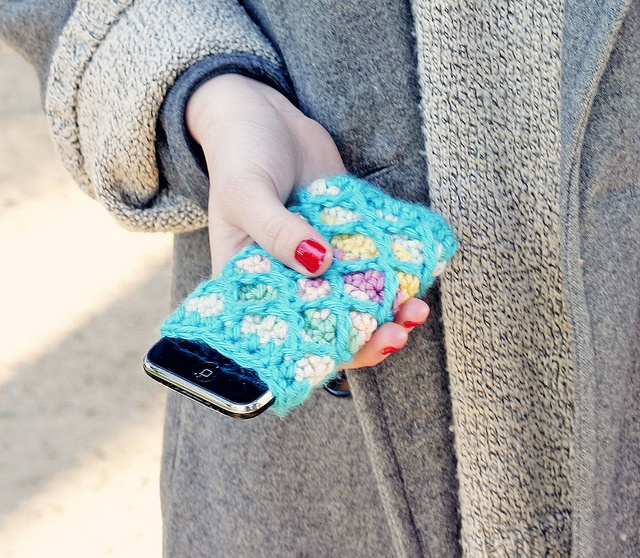Describe the objects in this image and their specific colors. I can see people in darkgray, gray, and lightgray tones and cell phone in darkgray, black, navy, and lightgray tones in this image. 